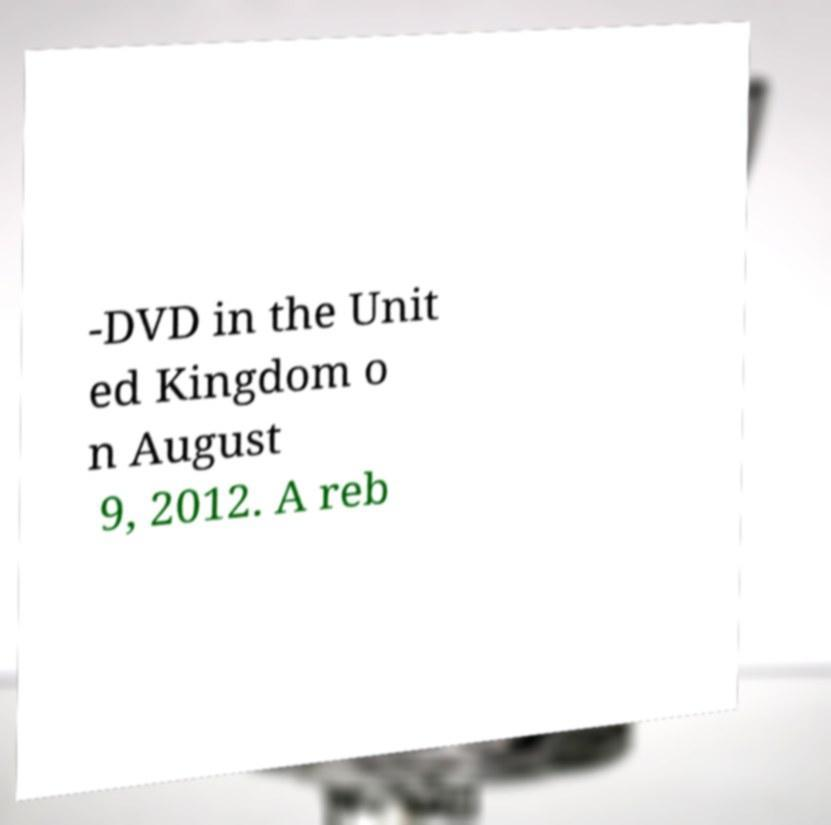Could you extract and type out the text from this image? -DVD in the Unit ed Kingdom o n August 9, 2012. A reb 